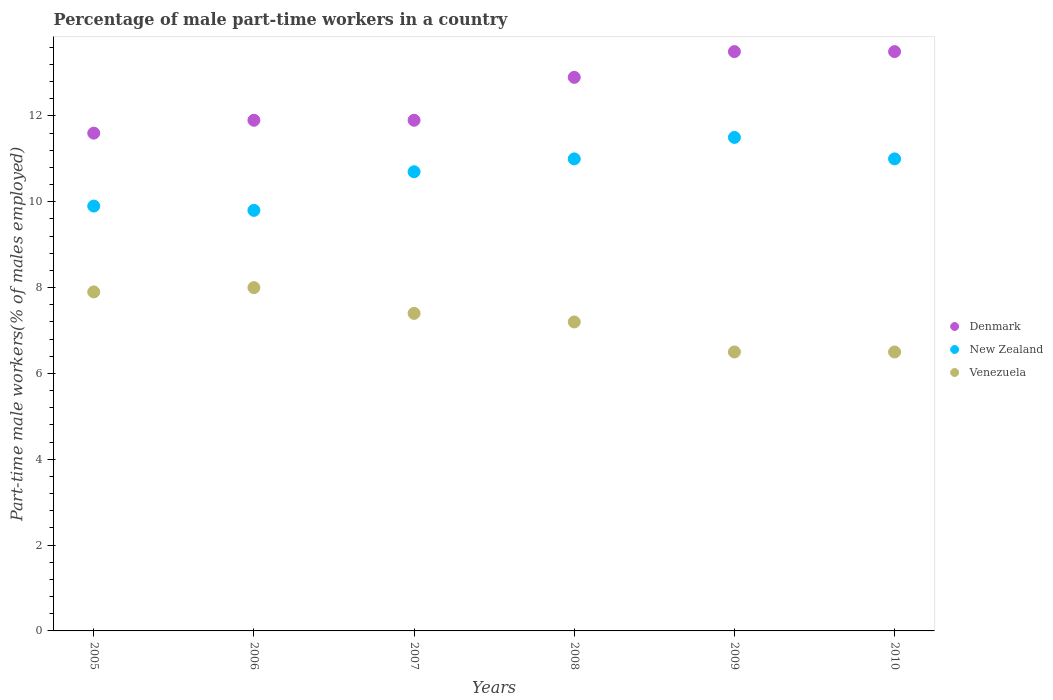How many different coloured dotlines are there?
Make the answer very short. 3. What is the percentage of male part-time workers in New Zealand in 2009?
Ensure brevity in your answer.  11.5. Across all years, what is the minimum percentage of male part-time workers in Denmark?
Give a very brief answer. 11.6. In which year was the percentage of male part-time workers in Denmark maximum?
Your answer should be compact. 2009. What is the total percentage of male part-time workers in Denmark in the graph?
Your answer should be compact. 75.3. What is the difference between the percentage of male part-time workers in Venezuela in 2005 and that in 2009?
Give a very brief answer. 1.4. What is the difference between the percentage of male part-time workers in Denmark in 2005 and the percentage of male part-time workers in New Zealand in 2007?
Your answer should be compact. 0.9. What is the average percentage of male part-time workers in New Zealand per year?
Provide a succinct answer. 10.65. In the year 2008, what is the difference between the percentage of male part-time workers in Venezuela and percentage of male part-time workers in Denmark?
Keep it short and to the point. -5.7. In how many years, is the percentage of male part-time workers in Denmark greater than 3.2 %?
Provide a succinct answer. 6. What is the ratio of the percentage of male part-time workers in New Zealand in 2006 to that in 2010?
Offer a terse response. 0.89. Is the difference between the percentage of male part-time workers in Venezuela in 2007 and 2009 greater than the difference between the percentage of male part-time workers in Denmark in 2007 and 2009?
Your response must be concise. Yes. What is the difference between the highest and the lowest percentage of male part-time workers in Denmark?
Ensure brevity in your answer.  1.9. In how many years, is the percentage of male part-time workers in Denmark greater than the average percentage of male part-time workers in Denmark taken over all years?
Offer a terse response. 3. Is the sum of the percentage of male part-time workers in New Zealand in 2008 and 2009 greater than the maximum percentage of male part-time workers in Venezuela across all years?
Ensure brevity in your answer.  Yes. How many dotlines are there?
Ensure brevity in your answer.  3. What is the difference between two consecutive major ticks on the Y-axis?
Your answer should be very brief. 2. Are the values on the major ticks of Y-axis written in scientific E-notation?
Ensure brevity in your answer.  No. Does the graph contain grids?
Offer a terse response. No. Where does the legend appear in the graph?
Your answer should be very brief. Center right. How many legend labels are there?
Your response must be concise. 3. What is the title of the graph?
Keep it short and to the point. Percentage of male part-time workers in a country. What is the label or title of the Y-axis?
Offer a very short reply. Part-time male workers(% of males employed). What is the Part-time male workers(% of males employed) of Denmark in 2005?
Offer a terse response. 11.6. What is the Part-time male workers(% of males employed) of New Zealand in 2005?
Provide a succinct answer. 9.9. What is the Part-time male workers(% of males employed) in Venezuela in 2005?
Ensure brevity in your answer.  7.9. What is the Part-time male workers(% of males employed) of Denmark in 2006?
Your response must be concise. 11.9. What is the Part-time male workers(% of males employed) of New Zealand in 2006?
Ensure brevity in your answer.  9.8. What is the Part-time male workers(% of males employed) in Venezuela in 2006?
Give a very brief answer. 8. What is the Part-time male workers(% of males employed) of Denmark in 2007?
Provide a short and direct response. 11.9. What is the Part-time male workers(% of males employed) in New Zealand in 2007?
Offer a terse response. 10.7. What is the Part-time male workers(% of males employed) of Venezuela in 2007?
Provide a short and direct response. 7.4. What is the Part-time male workers(% of males employed) in Denmark in 2008?
Keep it short and to the point. 12.9. What is the Part-time male workers(% of males employed) of New Zealand in 2008?
Give a very brief answer. 11. What is the Part-time male workers(% of males employed) in Venezuela in 2008?
Give a very brief answer. 7.2. What is the Part-time male workers(% of males employed) of Venezuela in 2009?
Keep it short and to the point. 6.5. What is the Part-time male workers(% of males employed) in Denmark in 2010?
Offer a very short reply. 13.5. What is the Part-time male workers(% of males employed) in Venezuela in 2010?
Offer a terse response. 6.5. Across all years, what is the maximum Part-time male workers(% of males employed) of Denmark?
Ensure brevity in your answer.  13.5. Across all years, what is the maximum Part-time male workers(% of males employed) of New Zealand?
Your response must be concise. 11.5. Across all years, what is the maximum Part-time male workers(% of males employed) in Venezuela?
Provide a short and direct response. 8. Across all years, what is the minimum Part-time male workers(% of males employed) of Denmark?
Your response must be concise. 11.6. Across all years, what is the minimum Part-time male workers(% of males employed) of New Zealand?
Your response must be concise. 9.8. What is the total Part-time male workers(% of males employed) in Denmark in the graph?
Your answer should be very brief. 75.3. What is the total Part-time male workers(% of males employed) in New Zealand in the graph?
Your answer should be compact. 63.9. What is the total Part-time male workers(% of males employed) in Venezuela in the graph?
Keep it short and to the point. 43.5. What is the difference between the Part-time male workers(% of males employed) of Denmark in 2005 and that in 2006?
Your response must be concise. -0.3. What is the difference between the Part-time male workers(% of males employed) in Venezuela in 2005 and that in 2006?
Provide a short and direct response. -0.1. What is the difference between the Part-time male workers(% of males employed) of Denmark in 2005 and that in 2007?
Provide a short and direct response. -0.3. What is the difference between the Part-time male workers(% of males employed) in Denmark in 2005 and that in 2008?
Make the answer very short. -1.3. What is the difference between the Part-time male workers(% of males employed) of New Zealand in 2005 and that in 2008?
Offer a terse response. -1.1. What is the difference between the Part-time male workers(% of males employed) in Denmark in 2005 and that in 2009?
Keep it short and to the point. -1.9. What is the difference between the Part-time male workers(% of males employed) of Denmark in 2005 and that in 2010?
Your answer should be compact. -1.9. What is the difference between the Part-time male workers(% of males employed) in Venezuela in 2006 and that in 2007?
Make the answer very short. 0.6. What is the difference between the Part-time male workers(% of males employed) in Venezuela in 2006 and that in 2008?
Provide a succinct answer. 0.8. What is the difference between the Part-time male workers(% of males employed) of Denmark in 2006 and that in 2009?
Keep it short and to the point. -1.6. What is the difference between the Part-time male workers(% of males employed) of Venezuela in 2006 and that in 2009?
Your answer should be very brief. 1.5. What is the difference between the Part-time male workers(% of males employed) in New Zealand in 2006 and that in 2010?
Give a very brief answer. -1.2. What is the difference between the Part-time male workers(% of males employed) in Venezuela in 2007 and that in 2008?
Provide a succinct answer. 0.2. What is the difference between the Part-time male workers(% of males employed) in Venezuela in 2007 and that in 2009?
Your answer should be very brief. 0.9. What is the difference between the Part-time male workers(% of males employed) of New Zealand in 2007 and that in 2010?
Offer a terse response. -0.3. What is the difference between the Part-time male workers(% of males employed) in Denmark in 2008 and that in 2009?
Give a very brief answer. -0.6. What is the difference between the Part-time male workers(% of males employed) in New Zealand in 2008 and that in 2009?
Give a very brief answer. -0.5. What is the difference between the Part-time male workers(% of males employed) in New Zealand in 2008 and that in 2010?
Offer a very short reply. 0. What is the difference between the Part-time male workers(% of males employed) in Venezuela in 2008 and that in 2010?
Offer a very short reply. 0.7. What is the difference between the Part-time male workers(% of males employed) in Denmark in 2009 and that in 2010?
Your answer should be very brief. 0. What is the difference between the Part-time male workers(% of males employed) in Venezuela in 2009 and that in 2010?
Your response must be concise. 0. What is the difference between the Part-time male workers(% of males employed) in Denmark in 2005 and the Part-time male workers(% of males employed) in Venezuela in 2006?
Ensure brevity in your answer.  3.6. What is the difference between the Part-time male workers(% of males employed) in Denmark in 2005 and the Part-time male workers(% of males employed) in New Zealand in 2007?
Provide a succinct answer. 0.9. What is the difference between the Part-time male workers(% of males employed) in New Zealand in 2005 and the Part-time male workers(% of males employed) in Venezuela in 2008?
Offer a terse response. 2.7. What is the difference between the Part-time male workers(% of males employed) in Denmark in 2005 and the Part-time male workers(% of males employed) in New Zealand in 2009?
Offer a very short reply. 0.1. What is the difference between the Part-time male workers(% of males employed) in New Zealand in 2005 and the Part-time male workers(% of males employed) in Venezuela in 2009?
Offer a very short reply. 3.4. What is the difference between the Part-time male workers(% of males employed) in New Zealand in 2005 and the Part-time male workers(% of males employed) in Venezuela in 2010?
Provide a succinct answer. 3.4. What is the difference between the Part-time male workers(% of males employed) of Denmark in 2006 and the Part-time male workers(% of males employed) of New Zealand in 2007?
Make the answer very short. 1.2. What is the difference between the Part-time male workers(% of males employed) of New Zealand in 2006 and the Part-time male workers(% of males employed) of Venezuela in 2007?
Make the answer very short. 2.4. What is the difference between the Part-time male workers(% of males employed) of Denmark in 2006 and the Part-time male workers(% of males employed) of Venezuela in 2008?
Ensure brevity in your answer.  4.7. What is the difference between the Part-time male workers(% of males employed) in New Zealand in 2006 and the Part-time male workers(% of males employed) in Venezuela in 2010?
Provide a succinct answer. 3.3. What is the difference between the Part-time male workers(% of males employed) in New Zealand in 2007 and the Part-time male workers(% of males employed) in Venezuela in 2008?
Provide a succinct answer. 3.5. What is the difference between the Part-time male workers(% of males employed) of Denmark in 2007 and the Part-time male workers(% of males employed) of New Zealand in 2009?
Give a very brief answer. 0.4. What is the difference between the Part-time male workers(% of males employed) in New Zealand in 2007 and the Part-time male workers(% of males employed) in Venezuela in 2009?
Offer a terse response. 4.2. What is the difference between the Part-time male workers(% of males employed) of New Zealand in 2007 and the Part-time male workers(% of males employed) of Venezuela in 2010?
Keep it short and to the point. 4.2. What is the difference between the Part-time male workers(% of males employed) in Denmark in 2008 and the Part-time male workers(% of males employed) in New Zealand in 2009?
Keep it short and to the point. 1.4. What is the difference between the Part-time male workers(% of males employed) in Denmark in 2008 and the Part-time male workers(% of males employed) in New Zealand in 2010?
Give a very brief answer. 1.9. What is the difference between the Part-time male workers(% of males employed) of New Zealand in 2008 and the Part-time male workers(% of males employed) of Venezuela in 2010?
Make the answer very short. 4.5. What is the difference between the Part-time male workers(% of males employed) in Denmark in 2009 and the Part-time male workers(% of males employed) in New Zealand in 2010?
Offer a very short reply. 2.5. What is the average Part-time male workers(% of males employed) in Denmark per year?
Offer a terse response. 12.55. What is the average Part-time male workers(% of males employed) of New Zealand per year?
Your answer should be very brief. 10.65. What is the average Part-time male workers(% of males employed) in Venezuela per year?
Make the answer very short. 7.25. In the year 2005, what is the difference between the Part-time male workers(% of males employed) in Denmark and Part-time male workers(% of males employed) in Venezuela?
Offer a very short reply. 3.7. In the year 2005, what is the difference between the Part-time male workers(% of males employed) of New Zealand and Part-time male workers(% of males employed) of Venezuela?
Offer a very short reply. 2. In the year 2006, what is the difference between the Part-time male workers(% of males employed) of Denmark and Part-time male workers(% of males employed) of New Zealand?
Offer a very short reply. 2.1. In the year 2006, what is the difference between the Part-time male workers(% of males employed) in New Zealand and Part-time male workers(% of males employed) in Venezuela?
Make the answer very short. 1.8. In the year 2007, what is the difference between the Part-time male workers(% of males employed) of Denmark and Part-time male workers(% of males employed) of New Zealand?
Your answer should be very brief. 1.2. In the year 2008, what is the difference between the Part-time male workers(% of males employed) of Denmark and Part-time male workers(% of males employed) of New Zealand?
Your answer should be very brief. 1.9. In the year 2009, what is the difference between the Part-time male workers(% of males employed) of Denmark and Part-time male workers(% of males employed) of New Zealand?
Offer a very short reply. 2. What is the ratio of the Part-time male workers(% of males employed) in Denmark in 2005 to that in 2006?
Provide a short and direct response. 0.97. What is the ratio of the Part-time male workers(% of males employed) in New Zealand in 2005 to that in 2006?
Your answer should be compact. 1.01. What is the ratio of the Part-time male workers(% of males employed) of Venezuela in 2005 to that in 2006?
Make the answer very short. 0.99. What is the ratio of the Part-time male workers(% of males employed) of Denmark in 2005 to that in 2007?
Make the answer very short. 0.97. What is the ratio of the Part-time male workers(% of males employed) in New Zealand in 2005 to that in 2007?
Offer a very short reply. 0.93. What is the ratio of the Part-time male workers(% of males employed) of Venezuela in 2005 to that in 2007?
Provide a short and direct response. 1.07. What is the ratio of the Part-time male workers(% of males employed) of Denmark in 2005 to that in 2008?
Give a very brief answer. 0.9. What is the ratio of the Part-time male workers(% of males employed) in Venezuela in 2005 to that in 2008?
Give a very brief answer. 1.1. What is the ratio of the Part-time male workers(% of males employed) of Denmark in 2005 to that in 2009?
Provide a succinct answer. 0.86. What is the ratio of the Part-time male workers(% of males employed) in New Zealand in 2005 to that in 2009?
Ensure brevity in your answer.  0.86. What is the ratio of the Part-time male workers(% of males employed) in Venezuela in 2005 to that in 2009?
Provide a succinct answer. 1.22. What is the ratio of the Part-time male workers(% of males employed) in Denmark in 2005 to that in 2010?
Give a very brief answer. 0.86. What is the ratio of the Part-time male workers(% of males employed) of New Zealand in 2005 to that in 2010?
Offer a very short reply. 0.9. What is the ratio of the Part-time male workers(% of males employed) in Venezuela in 2005 to that in 2010?
Keep it short and to the point. 1.22. What is the ratio of the Part-time male workers(% of males employed) of Denmark in 2006 to that in 2007?
Offer a very short reply. 1. What is the ratio of the Part-time male workers(% of males employed) in New Zealand in 2006 to that in 2007?
Your answer should be very brief. 0.92. What is the ratio of the Part-time male workers(% of males employed) in Venezuela in 2006 to that in 2007?
Make the answer very short. 1.08. What is the ratio of the Part-time male workers(% of males employed) of Denmark in 2006 to that in 2008?
Offer a terse response. 0.92. What is the ratio of the Part-time male workers(% of males employed) of New Zealand in 2006 to that in 2008?
Keep it short and to the point. 0.89. What is the ratio of the Part-time male workers(% of males employed) of Venezuela in 2006 to that in 2008?
Give a very brief answer. 1.11. What is the ratio of the Part-time male workers(% of males employed) of Denmark in 2006 to that in 2009?
Your response must be concise. 0.88. What is the ratio of the Part-time male workers(% of males employed) of New Zealand in 2006 to that in 2009?
Ensure brevity in your answer.  0.85. What is the ratio of the Part-time male workers(% of males employed) in Venezuela in 2006 to that in 2009?
Give a very brief answer. 1.23. What is the ratio of the Part-time male workers(% of males employed) of Denmark in 2006 to that in 2010?
Ensure brevity in your answer.  0.88. What is the ratio of the Part-time male workers(% of males employed) in New Zealand in 2006 to that in 2010?
Give a very brief answer. 0.89. What is the ratio of the Part-time male workers(% of males employed) in Venezuela in 2006 to that in 2010?
Your answer should be very brief. 1.23. What is the ratio of the Part-time male workers(% of males employed) of Denmark in 2007 to that in 2008?
Make the answer very short. 0.92. What is the ratio of the Part-time male workers(% of males employed) in New Zealand in 2007 to that in 2008?
Give a very brief answer. 0.97. What is the ratio of the Part-time male workers(% of males employed) of Venezuela in 2007 to that in 2008?
Make the answer very short. 1.03. What is the ratio of the Part-time male workers(% of males employed) in Denmark in 2007 to that in 2009?
Your response must be concise. 0.88. What is the ratio of the Part-time male workers(% of males employed) of New Zealand in 2007 to that in 2009?
Your answer should be very brief. 0.93. What is the ratio of the Part-time male workers(% of males employed) in Venezuela in 2007 to that in 2009?
Offer a terse response. 1.14. What is the ratio of the Part-time male workers(% of males employed) in Denmark in 2007 to that in 2010?
Your response must be concise. 0.88. What is the ratio of the Part-time male workers(% of males employed) in New Zealand in 2007 to that in 2010?
Your response must be concise. 0.97. What is the ratio of the Part-time male workers(% of males employed) in Venezuela in 2007 to that in 2010?
Keep it short and to the point. 1.14. What is the ratio of the Part-time male workers(% of males employed) in Denmark in 2008 to that in 2009?
Give a very brief answer. 0.96. What is the ratio of the Part-time male workers(% of males employed) of New Zealand in 2008 to that in 2009?
Give a very brief answer. 0.96. What is the ratio of the Part-time male workers(% of males employed) in Venezuela in 2008 to that in 2009?
Your response must be concise. 1.11. What is the ratio of the Part-time male workers(% of males employed) in Denmark in 2008 to that in 2010?
Your answer should be very brief. 0.96. What is the ratio of the Part-time male workers(% of males employed) in Venezuela in 2008 to that in 2010?
Your answer should be very brief. 1.11. What is the ratio of the Part-time male workers(% of males employed) in New Zealand in 2009 to that in 2010?
Your answer should be compact. 1.05. What is the difference between the highest and the lowest Part-time male workers(% of males employed) in Denmark?
Ensure brevity in your answer.  1.9. What is the difference between the highest and the lowest Part-time male workers(% of males employed) of New Zealand?
Ensure brevity in your answer.  1.7. 